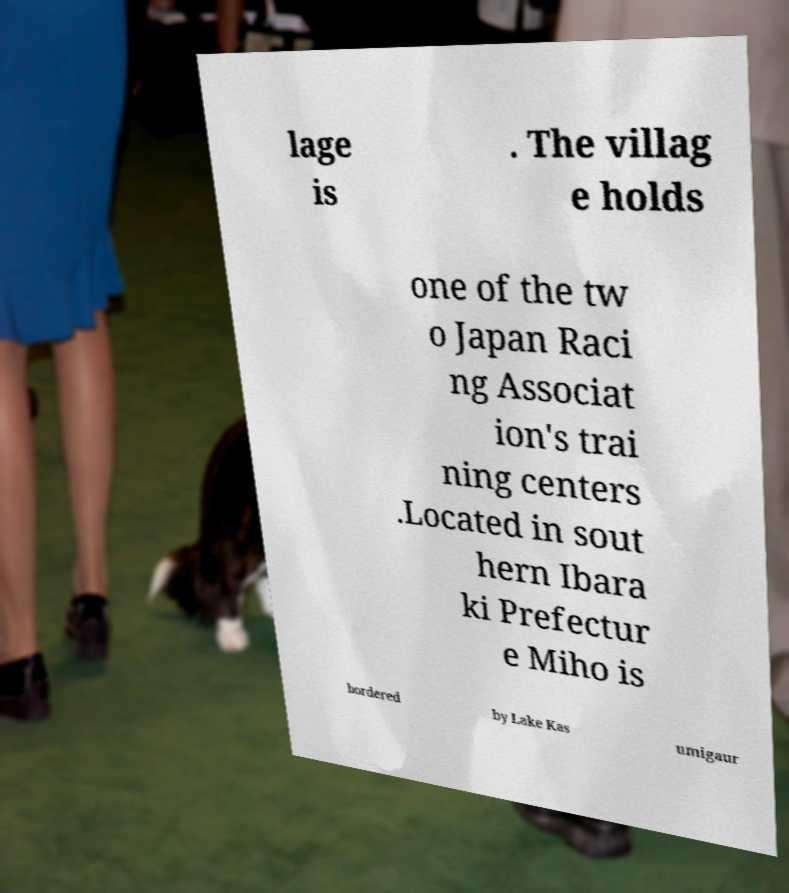Can you accurately transcribe the text from the provided image for me? lage is . The villag e holds one of the tw o Japan Raci ng Associat ion's trai ning centers .Located in sout hern Ibara ki Prefectur e Miho is bordered by Lake Kas umigaur 